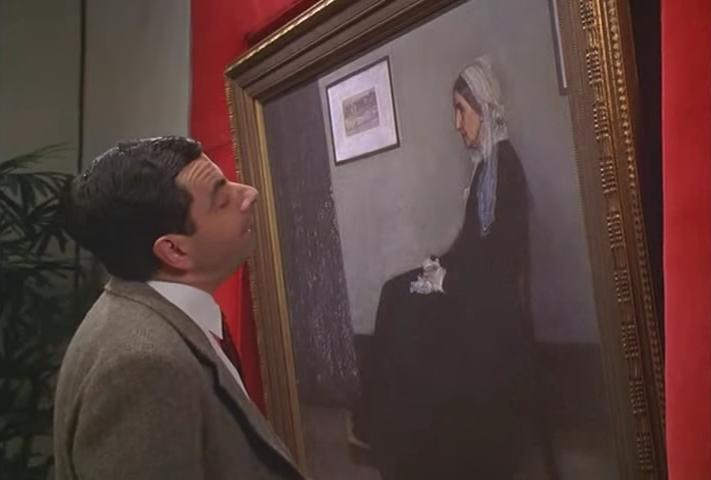What kind of emotions does the character seem to be expressing in relation to the painting? The character, with a whimsical imitation of contemplation, seems to express curiosity and perhaps a touch of bewilderment as he observes the painting. His head is slightly tilted, which, coupled with his facial expression, indicates he might be trying to understand or find a connection with the artwork, thus creating a playful tension between his comedic persona and the solemnity of the art piece. 